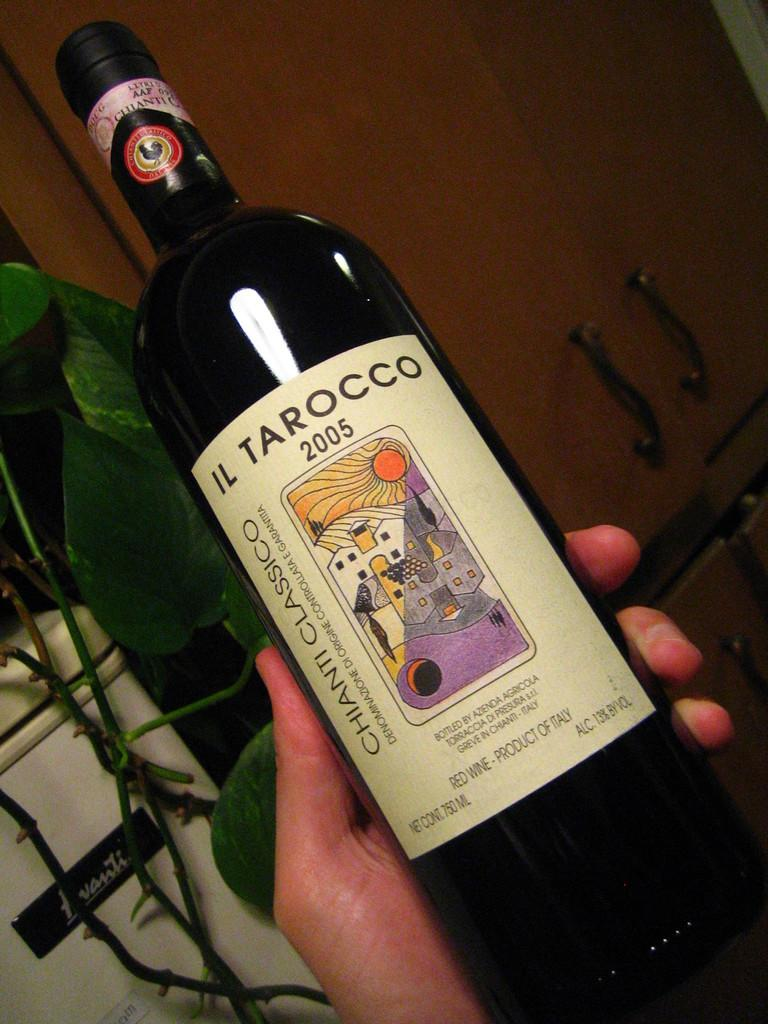Provide a one-sentence caption for the provided image. a bottle of Il Tarocco 2005 Chianti classico wine. 